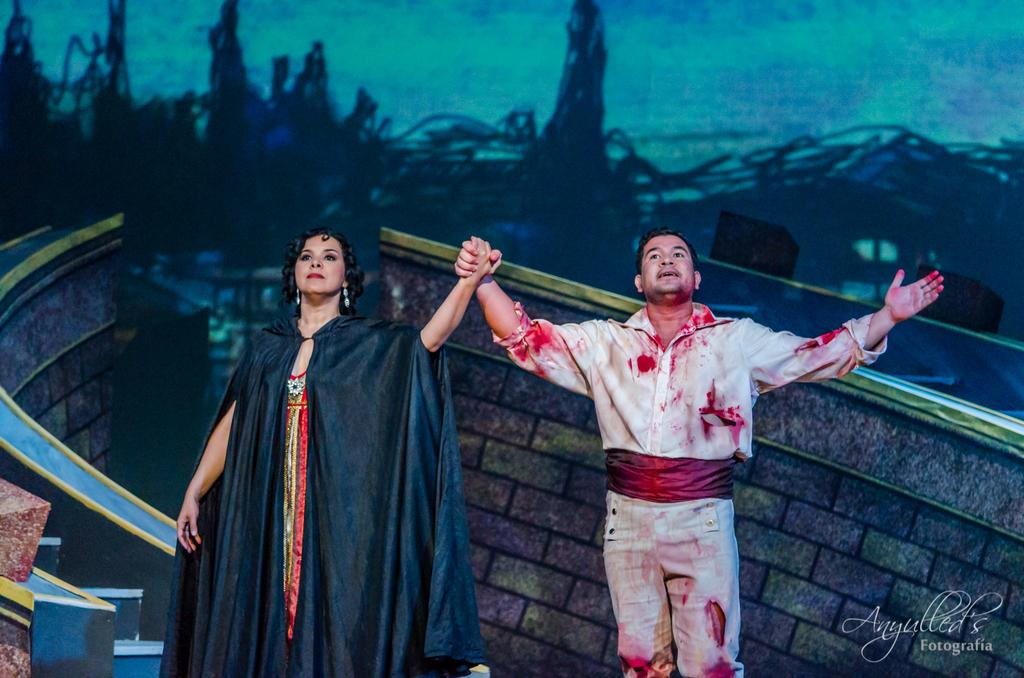Where was the image taken? The image is taken indoors. What can be seen on the wall in the background? There is a painting on the wall in the background. Who are the people in the image? A man and a woman are standing in the middle of the image. What surface are the man and woman standing on? The man and woman are standing on the floor. What type of fowl is present in the image? There is no fowl present in the image. What role does the minister play in the image? There is no minister present in the image. 